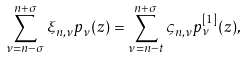<formula> <loc_0><loc_0><loc_500><loc_500>\sum _ { \nu = n - \sigma } ^ { n + \sigma } \xi _ { n , \nu } p _ { \nu } ( z ) = \sum _ { \nu = n - t } ^ { n + \sigma } \varsigma _ { n , \nu } p _ { \nu } ^ { [ 1 ] } ( z ) ,</formula> 